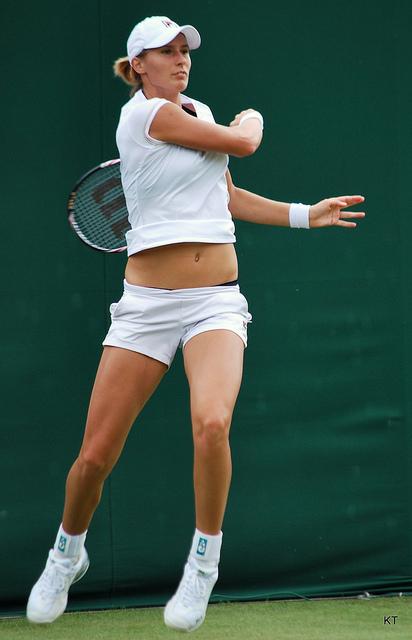What is on her left wrist?
Be succinct. Wristband. What color is the court?
Write a very short answer. Green. What sport does the woman play?
Quick response, please. Tennis. Is she wearing a dress?
Be succinct. No. Is this a vintage photo?
Quick response, please. No. Is the player wearing Bermuda shorts?
Write a very short answer. Yes. What is this woman wearing on her head?
Write a very short answer. Hat. Is this a man or a woman?
Quick response, please. Woman. What color are her shoes?
Be succinct. White. Why does the woman have on a wristband?
Keep it brief. Sweat. 